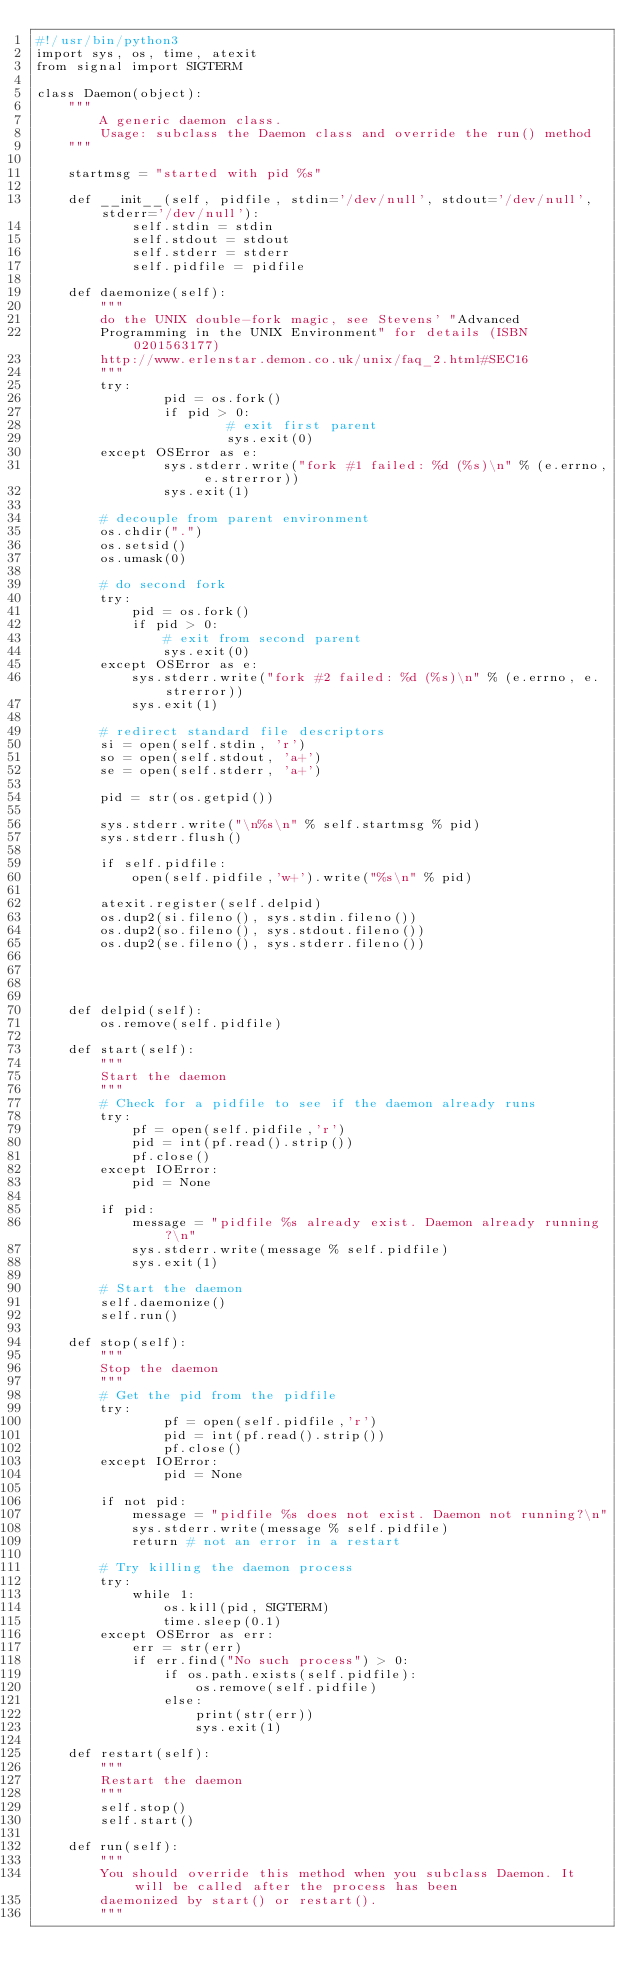Convert code to text. <code><loc_0><loc_0><loc_500><loc_500><_Python_>#!/usr/bin/python3
import sys, os, time, atexit
from signal import SIGTERM 

class Daemon(object):
	"""
		A generic daemon class.
		Usage: subclass the Daemon class and override the run() method
	"""

	startmsg = "started with pid %s"
	
	def __init__(self, pidfile, stdin='/dev/null', stdout='/dev/null', stderr='/dev/null'):
			self.stdin = stdin
			self.stdout = stdout
			self.stderr = stderr
			self.pidfile = pidfile

	def daemonize(self):
		"""
		do the UNIX double-fork magic, see Stevens' "Advanced 
		Programming in the UNIX Environment" for details (ISBN 0201563177)
		http://www.erlenstar.demon.co.uk/unix/faq_2.html#SEC16
		"""
		try: 
				pid = os.fork() 
				if pid > 0:
						# exit first parent
						sys.exit(0) 
		except OSError as e: 
				sys.stderr.write("fork #1 failed: %d (%s)\n" % (e.errno, e.strerror))
				sys.exit(1)

		# decouple from parent environment
		os.chdir(".") 
		os.setsid() 
		os.umask(0) 

		# do second fork
		try: 
			pid = os.fork() 
			if pid > 0:
				# exit from second parent
				sys.exit(0) 
		except OSError as e: 
			sys.stderr.write("fork #2 failed: %d (%s)\n" % (e.errno, e.strerror))
			sys.exit(1) 
		
		# redirect standard file descriptors
		si = open(self.stdin, 'r')
		so = open(self.stdout, 'a+')
		se = open(self.stderr, 'a+')
		
		pid = str(os.getpid())
		
		sys.stderr.write("\n%s\n" % self.startmsg % pid)
		sys.stderr.flush()

		if self.pidfile:
			open(self.pidfile,'w+').write("%s\n" % pid)
		
		atexit.register(self.delpid)
		os.dup2(si.fileno(), sys.stdin.fileno())
		os.dup2(so.fileno(), sys.stdout.fileno())
		os.dup2(se.fileno(), sys.stderr.fileno())
			
		
		

	def delpid(self):
		os.remove(self.pidfile)

	def start(self):
		"""
		Start the daemon
		"""
		# Check for a pidfile to see if the daemon already runs
		try:
			pf = open(self.pidfile,'r')
			pid = int(pf.read().strip())
			pf.close()
		except IOError:
			pid = None

		if pid:
			message = "pidfile %s already exist. Daemon already running?\n"
			sys.stderr.write(message % self.pidfile)
			sys.exit(1)

		# Start the daemon
		self.daemonize()
		self.run()

	def stop(self):
		"""
		Stop the daemon
		"""
		# Get the pid from the pidfile
		try:
				pf = open(self.pidfile,'r')
				pid = int(pf.read().strip())
				pf.close()
		except IOError:
				pid = None

		if not pid:
			message = "pidfile %s does not exist. Daemon not running?\n"
			sys.stderr.write(message % self.pidfile)
			return # not an error in a restart

		# Try killing the daemon process        
		try:
			while 1:
				os.kill(pid, SIGTERM)
				time.sleep(0.1)
		except OSError as err:
			err = str(err)
			if err.find("No such process") > 0:
				if os.path.exists(self.pidfile):
					os.remove(self.pidfile)
				else:
					print(str(err))
					sys.exit(1)

	def restart(self):
		"""
		Restart the daemon
		"""
		self.stop()
		self.start()

	def run(self):
		"""
		You should override this method when you subclass Daemon. It will be called after the process has been
		daemonized by start() or restart().
		"""</code> 